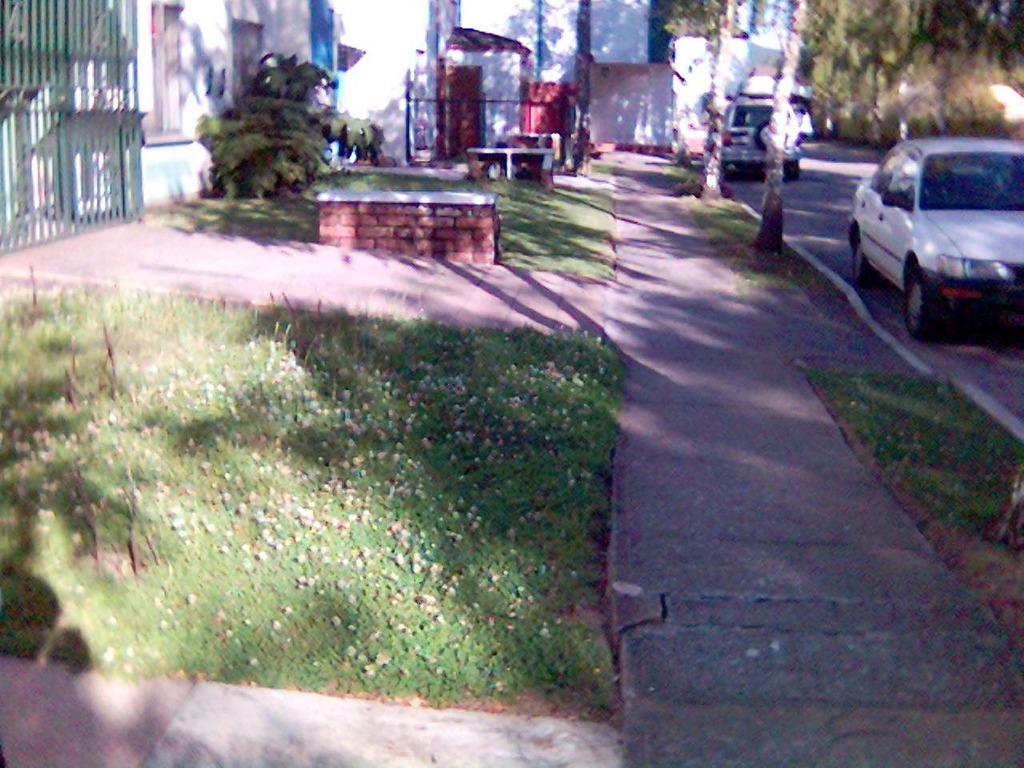What type of vegetation can be seen in the image? There is grass, plants, and trees in the image. What kind of surface is visible in the image? There is a path in the image. What structure is present in the image? There is a wall and a gate in the image. What else can be seen in the image besides the vegetation and structures? There are vehicles on the road in the image. What activity is the plant participating in within the image? There is no indication that the plants are participating in any activity within the image. Plants do not have the ability to participate in activities as humans do. 